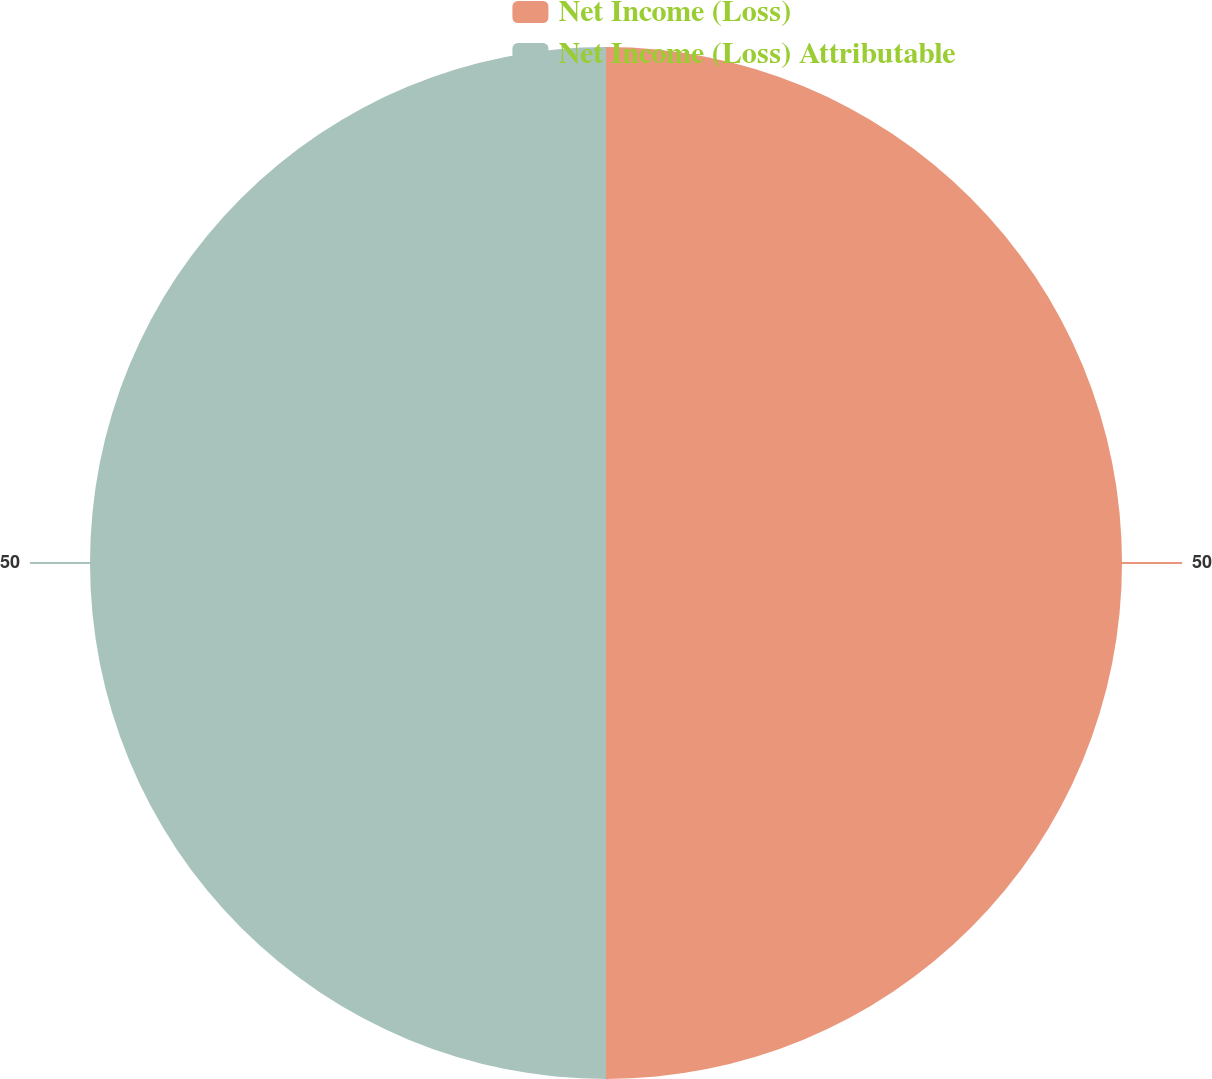<chart> <loc_0><loc_0><loc_500><loc_500><pie_chart><fcel>Net Income (Loss)<fcel>Net Income (Loss) Attributable<nl><fcel>50.0%<fcel>50.0%<nl></chart> 